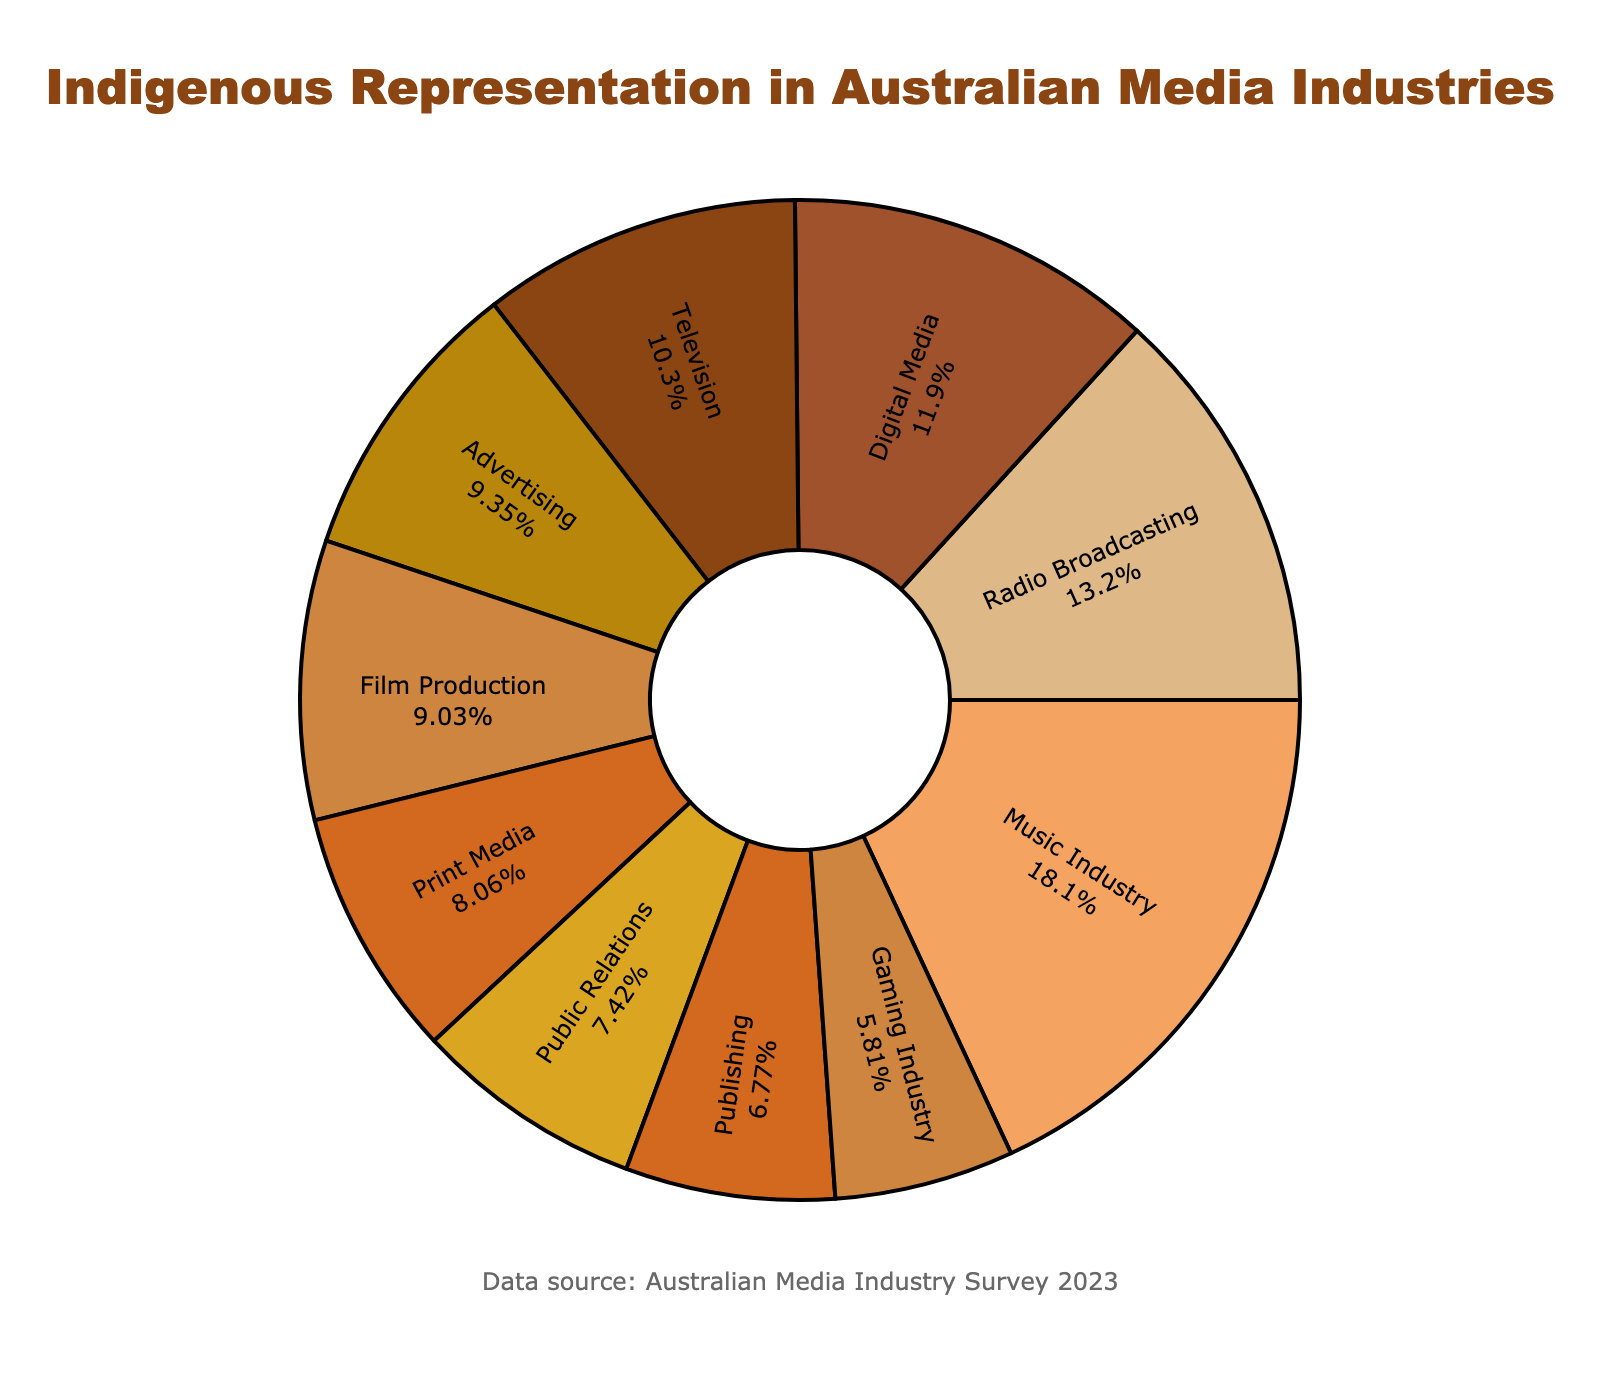What's the industry with the highest percentage of Indigenous representation? To determine the industry with the highest percentage, look for the largest segment in the pie chart labeled with the highest value. The Music Industry has the highest percentage at 5.6%.
Answer: Music Industry Which industry has the lowest Indigenous representation? To find the industry with the lowest representation, look for the smallest segment in the pie chart labeled with the lowest value. The Gaming Industry has the lowest percentage at 1.8%.
Answer: Gaming Industry What is the combined percentage of Indigenous representation in Television and Film Production? Add the percentages of the Television and Film Production segments. Television is 3.2% and Film Production is 2.8%, so the combined percentage is 3.2% + 2.8% = 6.0%.
Answer: 6.0% How does the Indigenous representation in Digital Media compare to Advertising? Compare the percentages of Digital Media and Advertising segments. Digital Media has 3.7% and Advertising has 2.9%. Digital Media has a higher percentage.
Answer: Digital Media Which industry has a percentage closest to 3%? Find the industry whose percentage is nearest to 3% by comparing each value. Advertising has a percentage of 2.9%, which is closest to 3%.
Answer: Advertising What is the average percentage of Indigenous representation across all industries? First, sum all the percentages and then divide by the number of industries. The total sum is 3.2 + 2.8 + 4.1 + 2.5 + 3.7 + 2.9 + 2.3 + 5.6 + 2.1 + 1.8 = 31.0. There are 10 industries, so the average is 31.0 / 10 = 3.1%.
Answer: 3.1% What's the difference in Indigenous representation between Radio Broadcasting and Print Media? Subtract the percentage of Print Media from the percentage of Radio Broadcasting. Radio Broadcasting is 4.1% and Print Media is 2.5%. The difference is 4.1% - 2.5% = 1.6%.
Answer: 1.6% Which industries have a percentage lower than the average Indigenous representation? First, determine the average percentage, which is 3.1%. Then, compare each industry’s percentage to see which are below this value. The industries are Film Production (2.8%), Print Media (2.5%), Advertising (2.9%), Public Relations (2.3%), Publishing (2.1%), and Gaming Industry (1.8%).
Answer: Film Production, Print Media, Advertising, Public Relations, Publishing, Gaming Industry What's the total percentage of Indigenous representation in Radio Broadcasting, Music Industry, and Digital Media? Add the percentages of these three industries. Radio Broadcasting is 4.1%, Music Industry is 5.6%, and Digital Media is 3.7%. The total is 4.1% + 5.6% + 3.7% = 13.4%.
Answer: 13.4% What is the second highest percentage of Indigenous representation after the Music Industry? Identify the highest percentage and then the next highest percentage. The highest is the Music Industry at 5.6%. The second highest is Radio Broadcasting at 4.1%.
Answer: Radio Broadcasting 